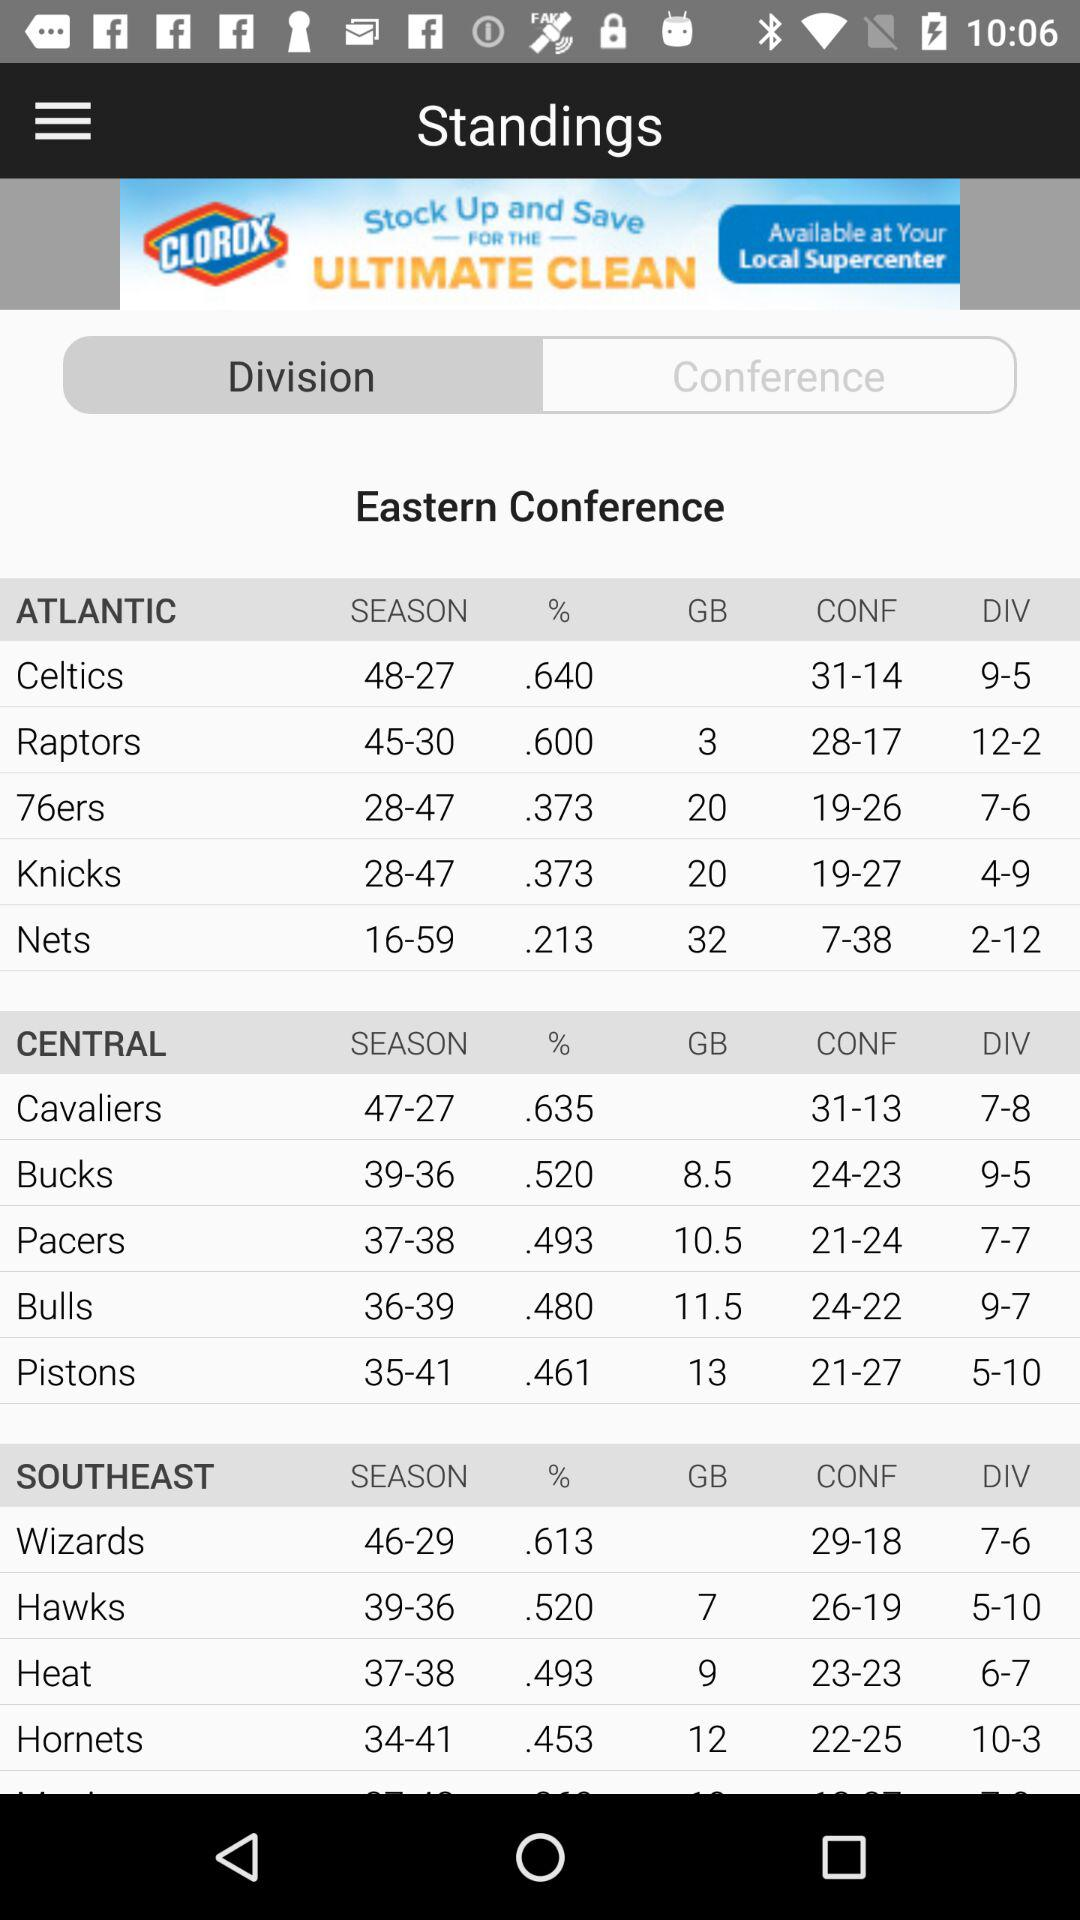What is the division of nets? The division of nets is 2-12. 